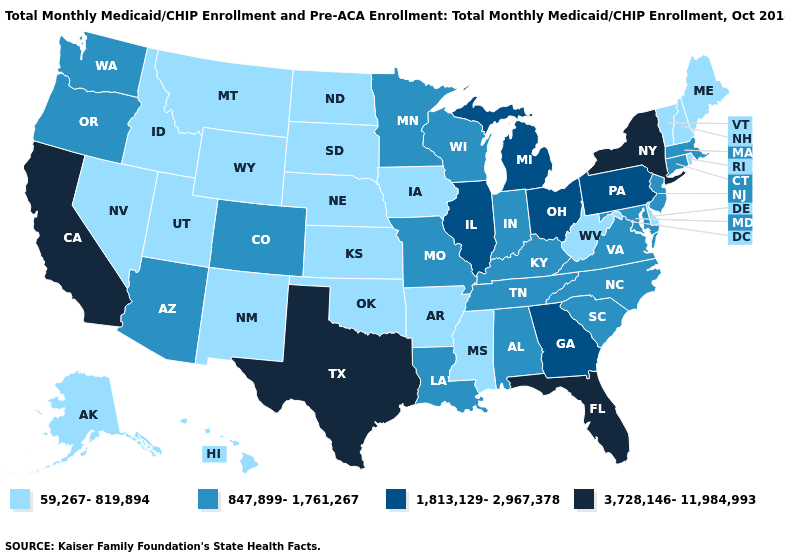Among the states that border Missouri , does Oklahoma have the lowest value?
Be succinct. Yes. What is the lowest value in the USA?
Short answer required. 59,267-819,894. What is the value of Kentucky?
Concise answer only. 847,899-1,761,267. Does Montana have a higher value than New York?
Short answer required. No. Does Utah have the highest value in the USA?
Concise answer only. No. Does Florida have the lowest value in the USA?
Concise answer only. No. What is the highest value in the West ?
Quick response, please. 3,728,146-11,984,993. Which states have the highest value in the USA?
Short answer required. California, Florida, New York, Texas. Does the first symbol in the legend represent the smallest category?
Short answer required. Yes. Does New York have the highest value in the Northeast?
Short answer required. Yes. Among the states that border Washington , which have the highest value?
Give a very brief answer. Oregon. What is the lowest value in the Northeast?
Quick response, please. 59,267-819,894. What is the lowest value in the USA?
Give a very brief answer. 59,267-819,894. Name the states that have a value in the range 59,267-819,894?
Answer briefly. Alaska, Arkansas, Delaware, Hawaii, Idaho, Iowa, Kansas, Maine, Mississippi, Montana, Nebraska, Nevada, New Hampshire, New Mexico, North Dakota, Oklahoma, Rhode Island, South Dakota, Utah, Vermont, West Virginia, Wyoming. Name the states that have a value in the range 1,813,129-2,967,378?
Concise answer only. Georgia, Illinois, Michigan, Ohio, Pennsylvania. 